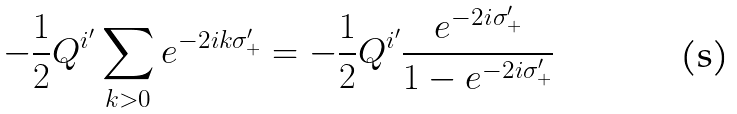Convert formula to latex. <formula><loc_0><loc_0><loc_500><loc_500>- \frac { 1 } { 2 } Q ^ { i ^ { \prime } } \sum _ { k > 0 } e ^ { - 2 i k \sigma _ { + } ^ { \prime } } = - \frac { 1 } { 2 } Q ^ { i ^ { \prime } } \frac { e ^ { - 2 i \sigma _ { + } ^ { \prime } } } { 1 - e ^ { - 2 i \sigma _ { + } ^ { \prime } } }</formula> 